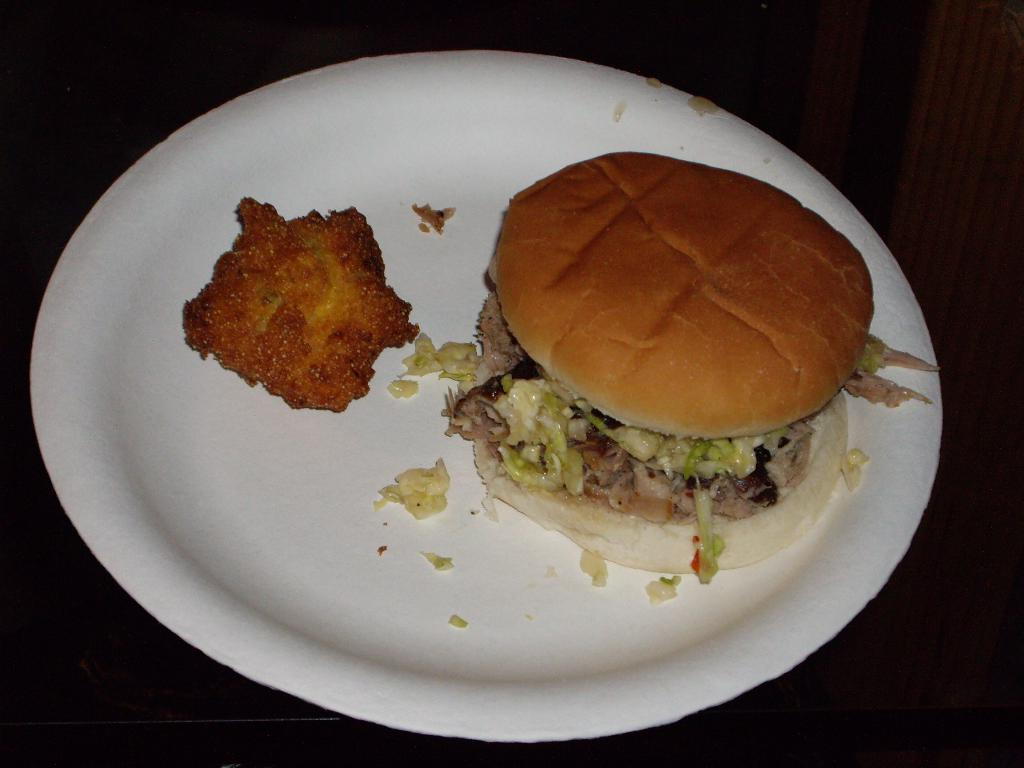What is on the plate that is visible in the image? There is a burger on the plate in the image. What else can be seen on the plate besides the burger? There is additional food present in the image. How would you describe the overall lighting in the image? The background of the image is dark. What type of building can be seen in the background of the image? There is no building present in the image; the background is dark. How does the burger look at the person taking the picture? The image does not show the perspective of a person taking a picture, so it cannot be determined how the burger looks to them. 